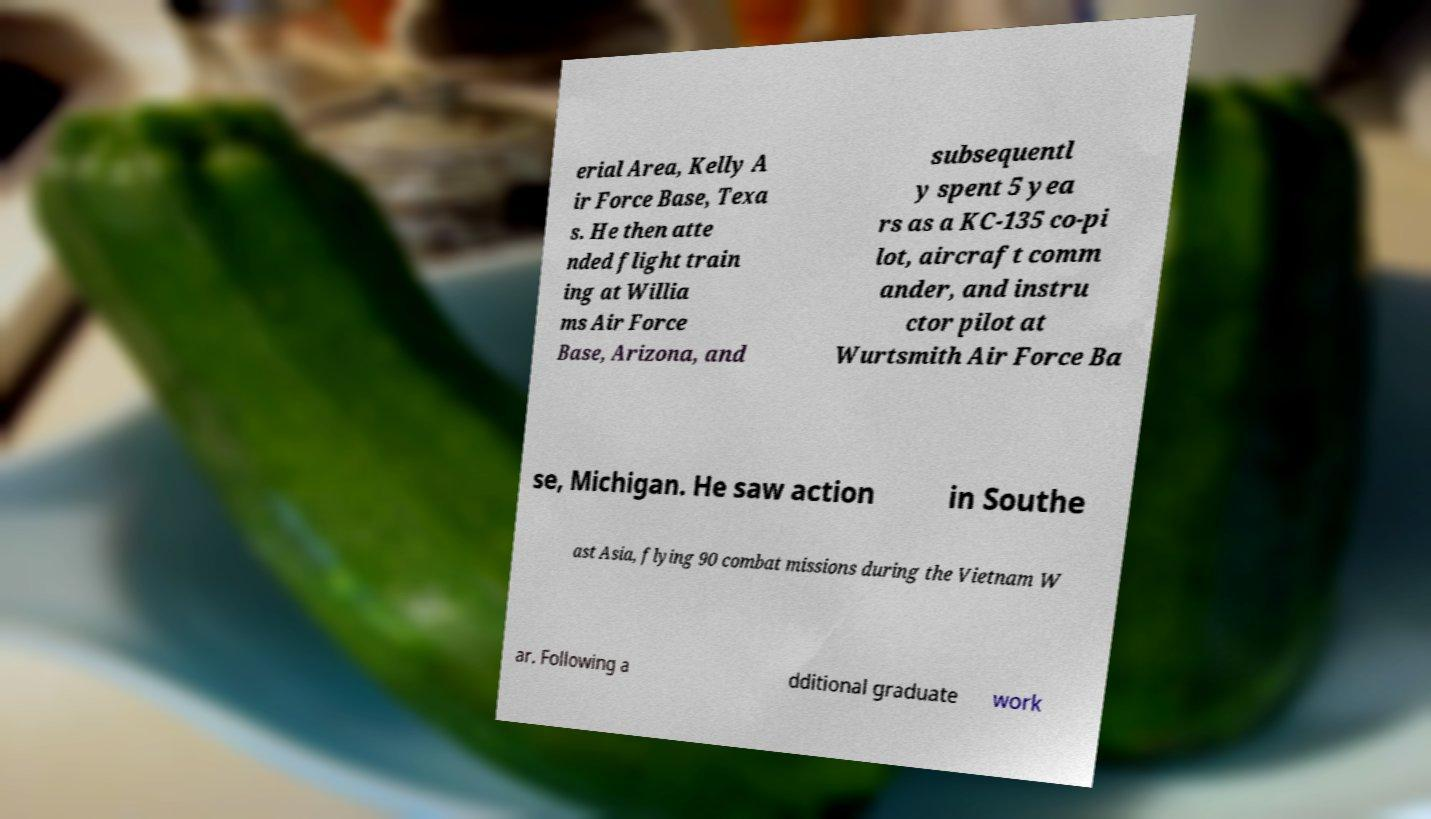Could you assist in decoding the text presented in this image and type it out clearly? erial Area, Kelly A ir Force Base, Texa s. He then atte nded flight train ing at Willia ms Air Force Base, Arizona, and subsequentl y spent 5 yea rs as a KC-135 co-pi lot, aircraft comm ander, and instru ctor pilot at Wurtsmith Air Force Ba se, Michigan. He saw action in Southe ast Asia, flying 90 combat missions during the Vietnam W ar. Following a dditional graduate work 